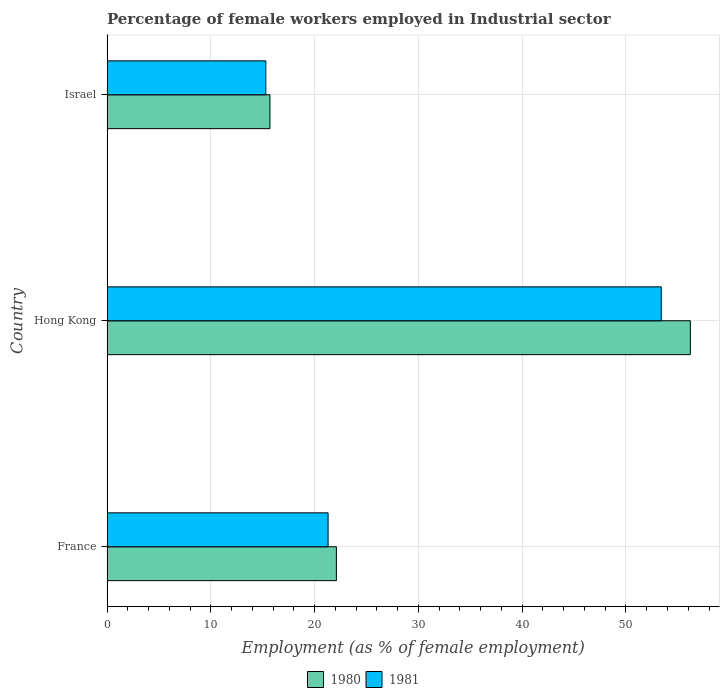How many different coloured bars are there?
Your answer should be compact. 2. How many groups of bars are there?
Your answer should be very brief. 3. Are the number of bars per tick equal to the number of legend labels?
Provide a short and direct response. Yes. What is the label of the 2nd group of bars from the top?
Your answer should be compact. Hong Kong. What is the percentage of females employed in Industrial sector in 1980 in Israel?
Provide a short and direct response. 15.7. Across all countries, what is the maximum percentage of females employed in Industrial sector in 1980?
Your answer should be very brief. 56.2. Across all countries, what is the minimum percentage of females employed in Industrial sector in 1980?
Keep it short and to the point. 15.7. In which country was the percentage of females employed in Industrial sector in 1980 maximum?
Offer a terse response. Hong Kong. What is the total percentage of females employed in Industrial sector in 1980 in the graph?
Offer a terse response. 94. What is the difference between the percentage of females employed in Industrial sector in 1981 in Hong Kong and that in Israel?
Keep it short and to the point. 38.1. What is the difference between the percentage of females employed in Industrial sector in 1981 in Hong Kong and the percentage of females employed in Industrial sector in 1980 in France?
Offer a very short reply. 31.3. What is the average percentage of females employed in Industrial sector in 1980 per country?
Offer a terse response. 31.33. What is the difference between the percentage of females employed in Industrial sector in 1980 and percentage of females employed in Industrial sector in 1981 in Hong Kong?
Offer a terse response. 2.8. In how many countries, is the percentage of females employed in Industrial sector in 1980 greater than 12 %?
Provide a short and direct response. 3. What is the ratio of the percentage of females employed in Industrial sector in 1980 in Hong Kong to that in Israel?
Your answer should be compact. 3.58. Is the percentage of females employed in Industrial sector in 1981 in France less than that in Israel?
Provide a short and direct response. No. What is the difference between the highest and the second highest percentage of females employed in Industrial sector in 1980?
Give a very brief answer. 34.1. What is the difference between the highest and the lowest percentage of females employed in Industrial sector in 1980?
Your response must be concise. 40.5. In how many countries, is the percentage of females employed in Industrial sector in 1981 greater than the average percentage of females employed in Industrial sector in 1981 taken over all countries?
Offer a very short reply. 1. Is the sum of the percentage of females employed in Industrial sector in 1980 in France and Israel greater than the maximum percentage of females employed in Industrial sector in 1981 across all countries?
Your response must be concise. No. What does the 1st bar from the top in France represents?
Give a very brief answer. 1981. How many bars are there?
Offer a terse response. 6. Are all the bars in the graph horizontal?
Provide a succinct answer. Yes. What is the difference between two consecutive major ticks on the X-axis?
Offer a terse response. 10. Are the values on the major ticks of X-axis written in scientific E-notation?
Your answer should be compact. No. Does the graph contain any zero values?
Your response must be concise. No. How many legend labels are there?
Your answer should be compact. 2. What is the title of the graph?
Your answer should be very brief. Percentage of female workers employed in Industrial sector. Does "1973" appear as one of the legend labels in the graph?
Your answer should be very brief. No. What is the label or title of the X-axis?
Make the answer very short. Employment (as % of female employment). What is the Employment (as % of female employment) of 1980 in France?
Offer a terse response. 22.1. What is the Employment (as % of female employment) of 1981 in France?
Provide a short and direct response. 21.3. What is the Employment (as % of female employment) in 1980 in Hong Kong?
Your answer should be compact. 56.2. What is the Employment (as % of female employment) in 1981 in Hong Kong?
Your answer should be very brief. 53.4. What is the Employment (as % of female employment) of 1980 in Israel?
Your answer should be very brief. 15.7. What is the Employment (as % of female employment) of 1981 in Israel?
Provide a succinct answer. 15.3. Across all countries, what is the maximum Employment (as % of female employment) of 1980?
Your response must be concise. 56.2. Across all countries, what is the maximum Employment (as % of female employment) in 1981?
Offer a terse response. 53.4. Across all countries, what is the minimum Employment (as % of female employment) of 1980?
Provide a succinct answer. 15.7. Across all countries, what is the minimum Employment (as % of female employment) of 1981?
Provide a succinct answer. 15.3. What is the total Employment (as % of female employment) of 1980 in the graph?
Your response must be concise. 94. What is the total Employment (as % of female employment) of 1981 in the graph?
Keep it short and to the point. 90. What is the difference between the Employment (as % of female employment) of 1980 in France and that in Hong Kong?
Offer a very short reply. -34.1. What is the difference between the Employment (as % of female employment) in 1981 in France and that in Hong Kong?
Offer a very short reply. -32.1. What is the difference between the Employment (as % of female employment) of 1981 in France and that in Israel?
Offer a terse response. 6. What is the difference between the Employment (as % of female employment) in 1980 in Hong Kong and that in Israel?
Give a very brief answer. 40.5. What is the difference between the Employment (as % of female employment) of 1981 in Hong Kong and that in Israel?
Make the answer very short. 38.1. What is the difference between the Employment (as % of female employment) of 1980 in France and the Employment (as % of female employment) of 1981 in Hong Kong?
Give a very brief answer. -31.3. What is the difference between the Employment (as % of female employment) in 1980 in France and the Employment (as % of female employment) in 1981 in Israel?
Provide a short and direct response. 6.8. What is the difference between the Employment (as % of female employment) of 1980 in Hong Kong and the Employment (as % of female employment) of 1981 in Israel?
Ensure brevity in your answer.  40.9. What is the average Employment (as % of female employment) of 1980 per country?
Give a very brief answer. 31.33. What is the difference between the Employment (as % of female employment) in 1980 and Employment (as % of female employment) in 1981 in Israel?
Ensure brevity in your answer.  0.4. What is the ratio of the Employment (as % of female employment) of 1980 in France to that in Hong Kong?
Your answer should be very brief. 0.39. What is the ratio of the Employment (as % of female employment) of 1981 in France to that in Hong Kong?
Make the answer very short. 0.4. What is the ratio of the Employment (as % of female employment) in 1980 in France to that in Israel?
Your answer should be compact. 1.41. What is the ratio of the Employment (as % of female employment) of 1981 in France to that in Israel?
Your answer should be very brief. 1.39. What is the ratio of the Employment (as % of female employment) in 1980 in Hong Kong to that in Israel?
Provide a succinct answer. 3.58. What is the ratio of the Employment (as % of female employment) of 1981 in Hong Kong to that in Israel?
Give a very brief answer. 3.49. What is the difference between the highest and the second highest Employment (as % of female employment) of 1980?
Keep it short and to the point. 34.1. What is the difference between the highest and the second highest Employment (as % of female employment) of 1981?
Offer a very short reply. 32.1. What is the difference between the highest and the lowest Employment (as % of female employment) of 1980?
Ensure brevity in your answer.  40.5. What is the difference between the highest and the lowest Employment (as % of female employment) in 1981?
Offer a very short reply. 38.1. 